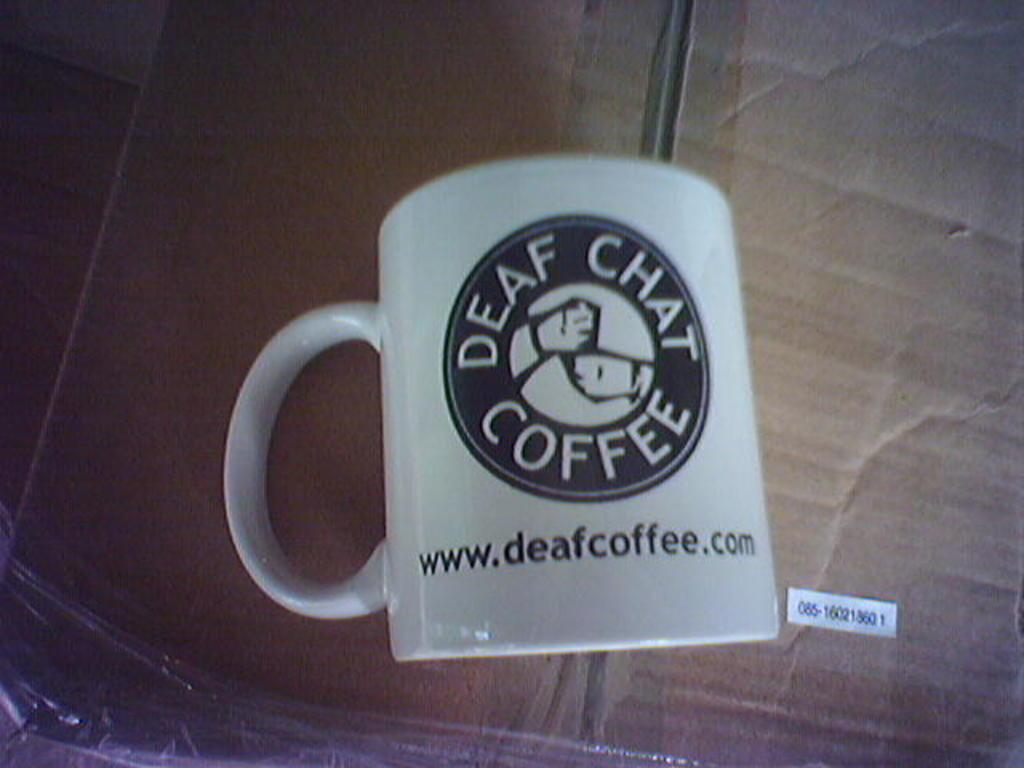<image>
Give a short and clear explanation of the subsequent image. A coffee mug with the words Deaf Chat Coffee written on it. 